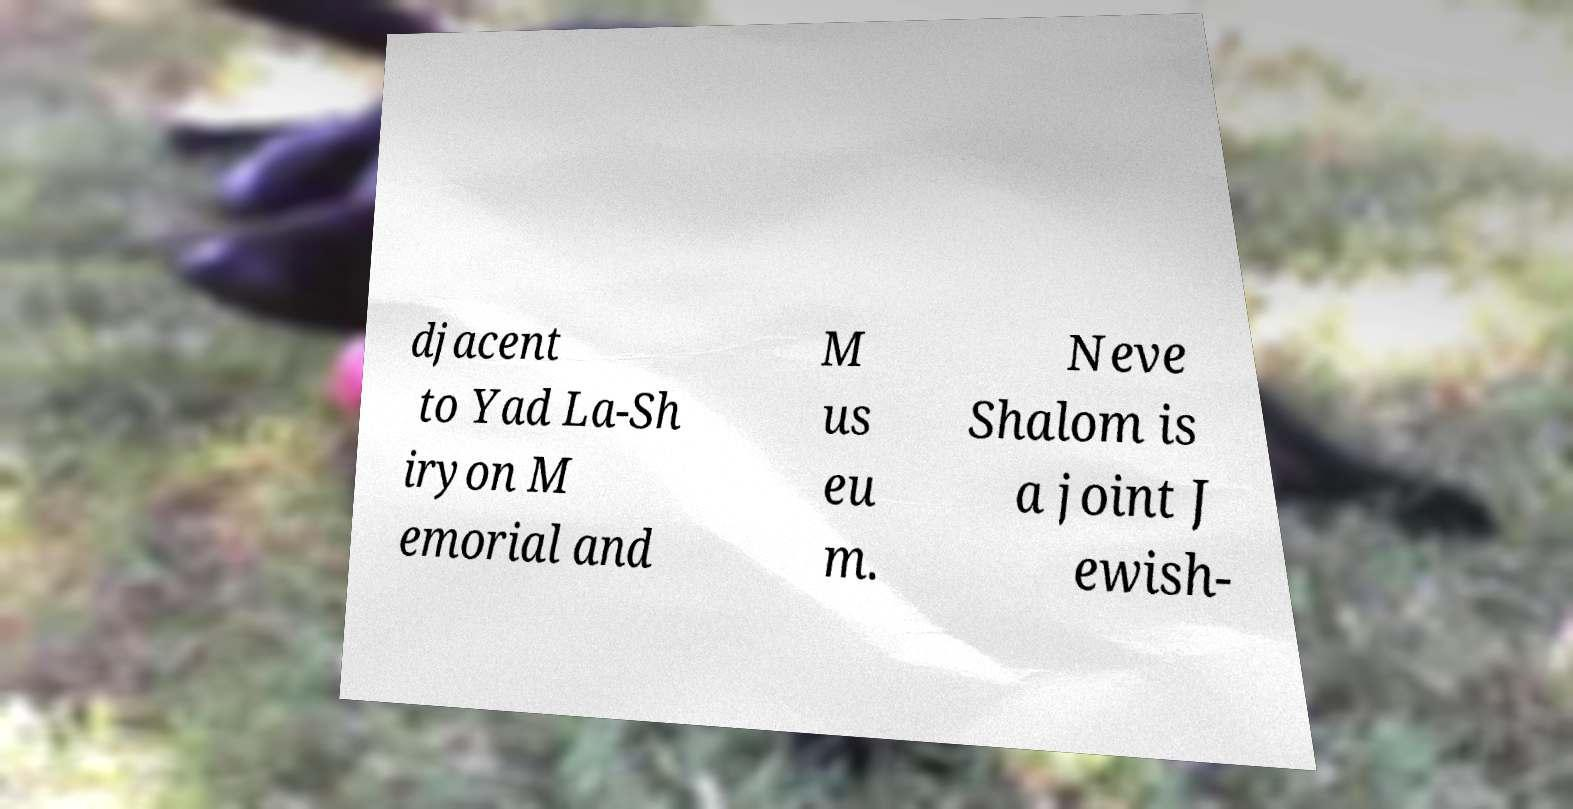Please identify and transcribe the text found in this image. djacent to Yad La-Sh iryon M emorial and M us eu m. Neve Shalom is a joint J ewish- 